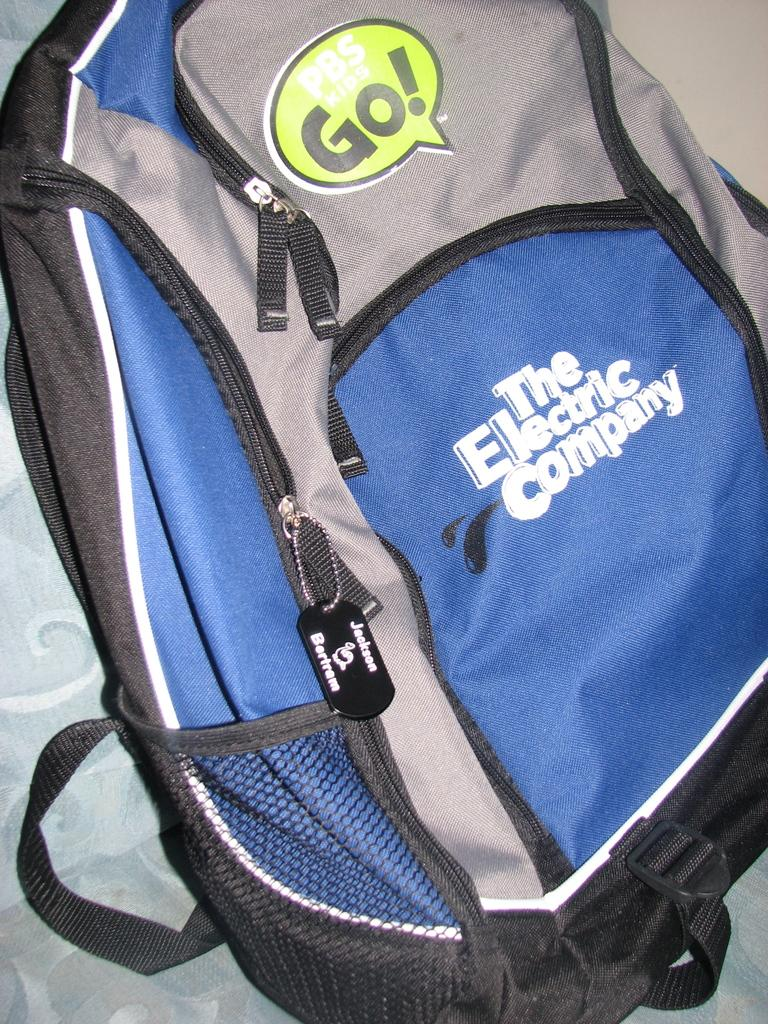<image>
Give a short and clear explanation of the subsequent image. A back pack has the words The Electric Company on it. 